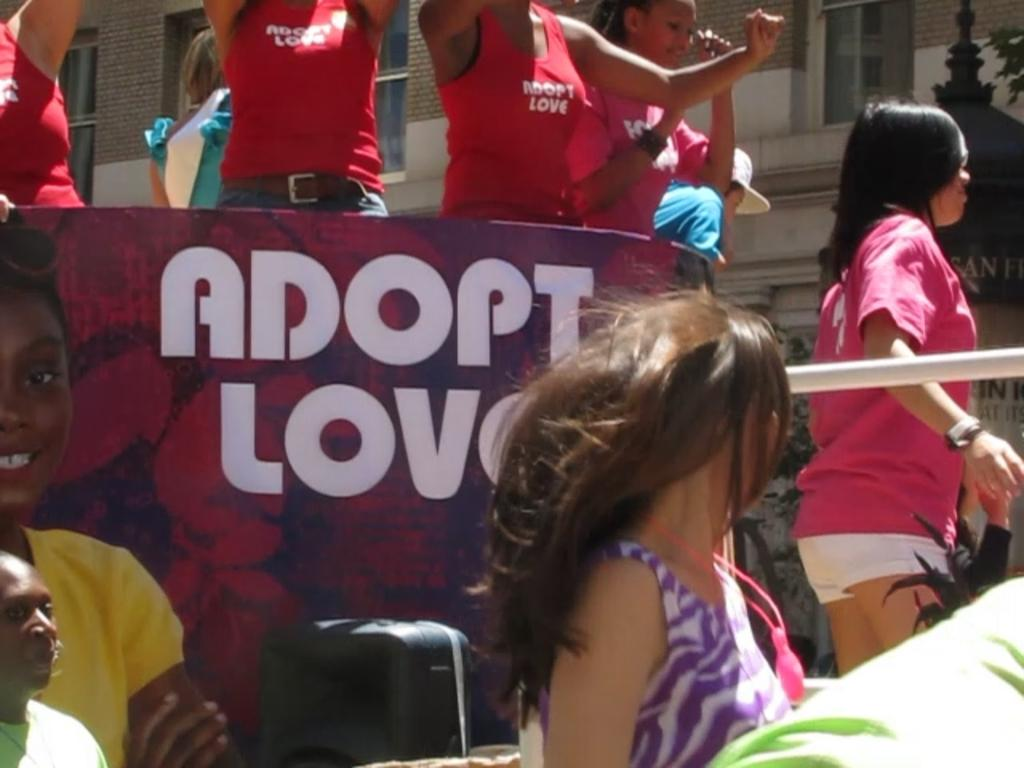<image>
Give a short and clear explanation of the subsequent image. A group of children are cheering around a sign that says Adopt Love. 